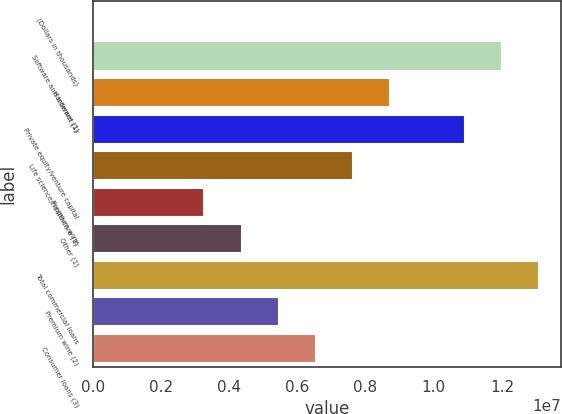Convert chart. <chart><loc_0><loc_0><loc_500><loc_500><bar_chart><fcel>(Dollars in thousands)<fcel>Software and internet (1)<fcel>Hardware (1)<fcel>Private equity/venture capital<fcel>Life science/healthcare (1)<fcel>Premium wine<fcel>Other (1)<fcel>Total commercial loans<fcel>Premium wine (2)<fcel>Consumer loans (3)<nl><fcel>2013<fcel>1.19968e+07<fcel>8.72551e+06<fcel>1.09064e+07<fcel>7.63507e+06<fcel>3.27332e+06<fcel>4.36376e+06<fcel>1.30873e+07<fcel>5.4542e+06<fcel>6.54464e+06<nl></chart> 